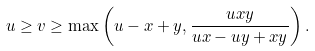<formula> <loc_0><loc_0><loc_500><loc_500>u \geq v \geq \max \left ( u - x + y , \frac { u x y } { u x - u y + x y } \right ) .</formula> 